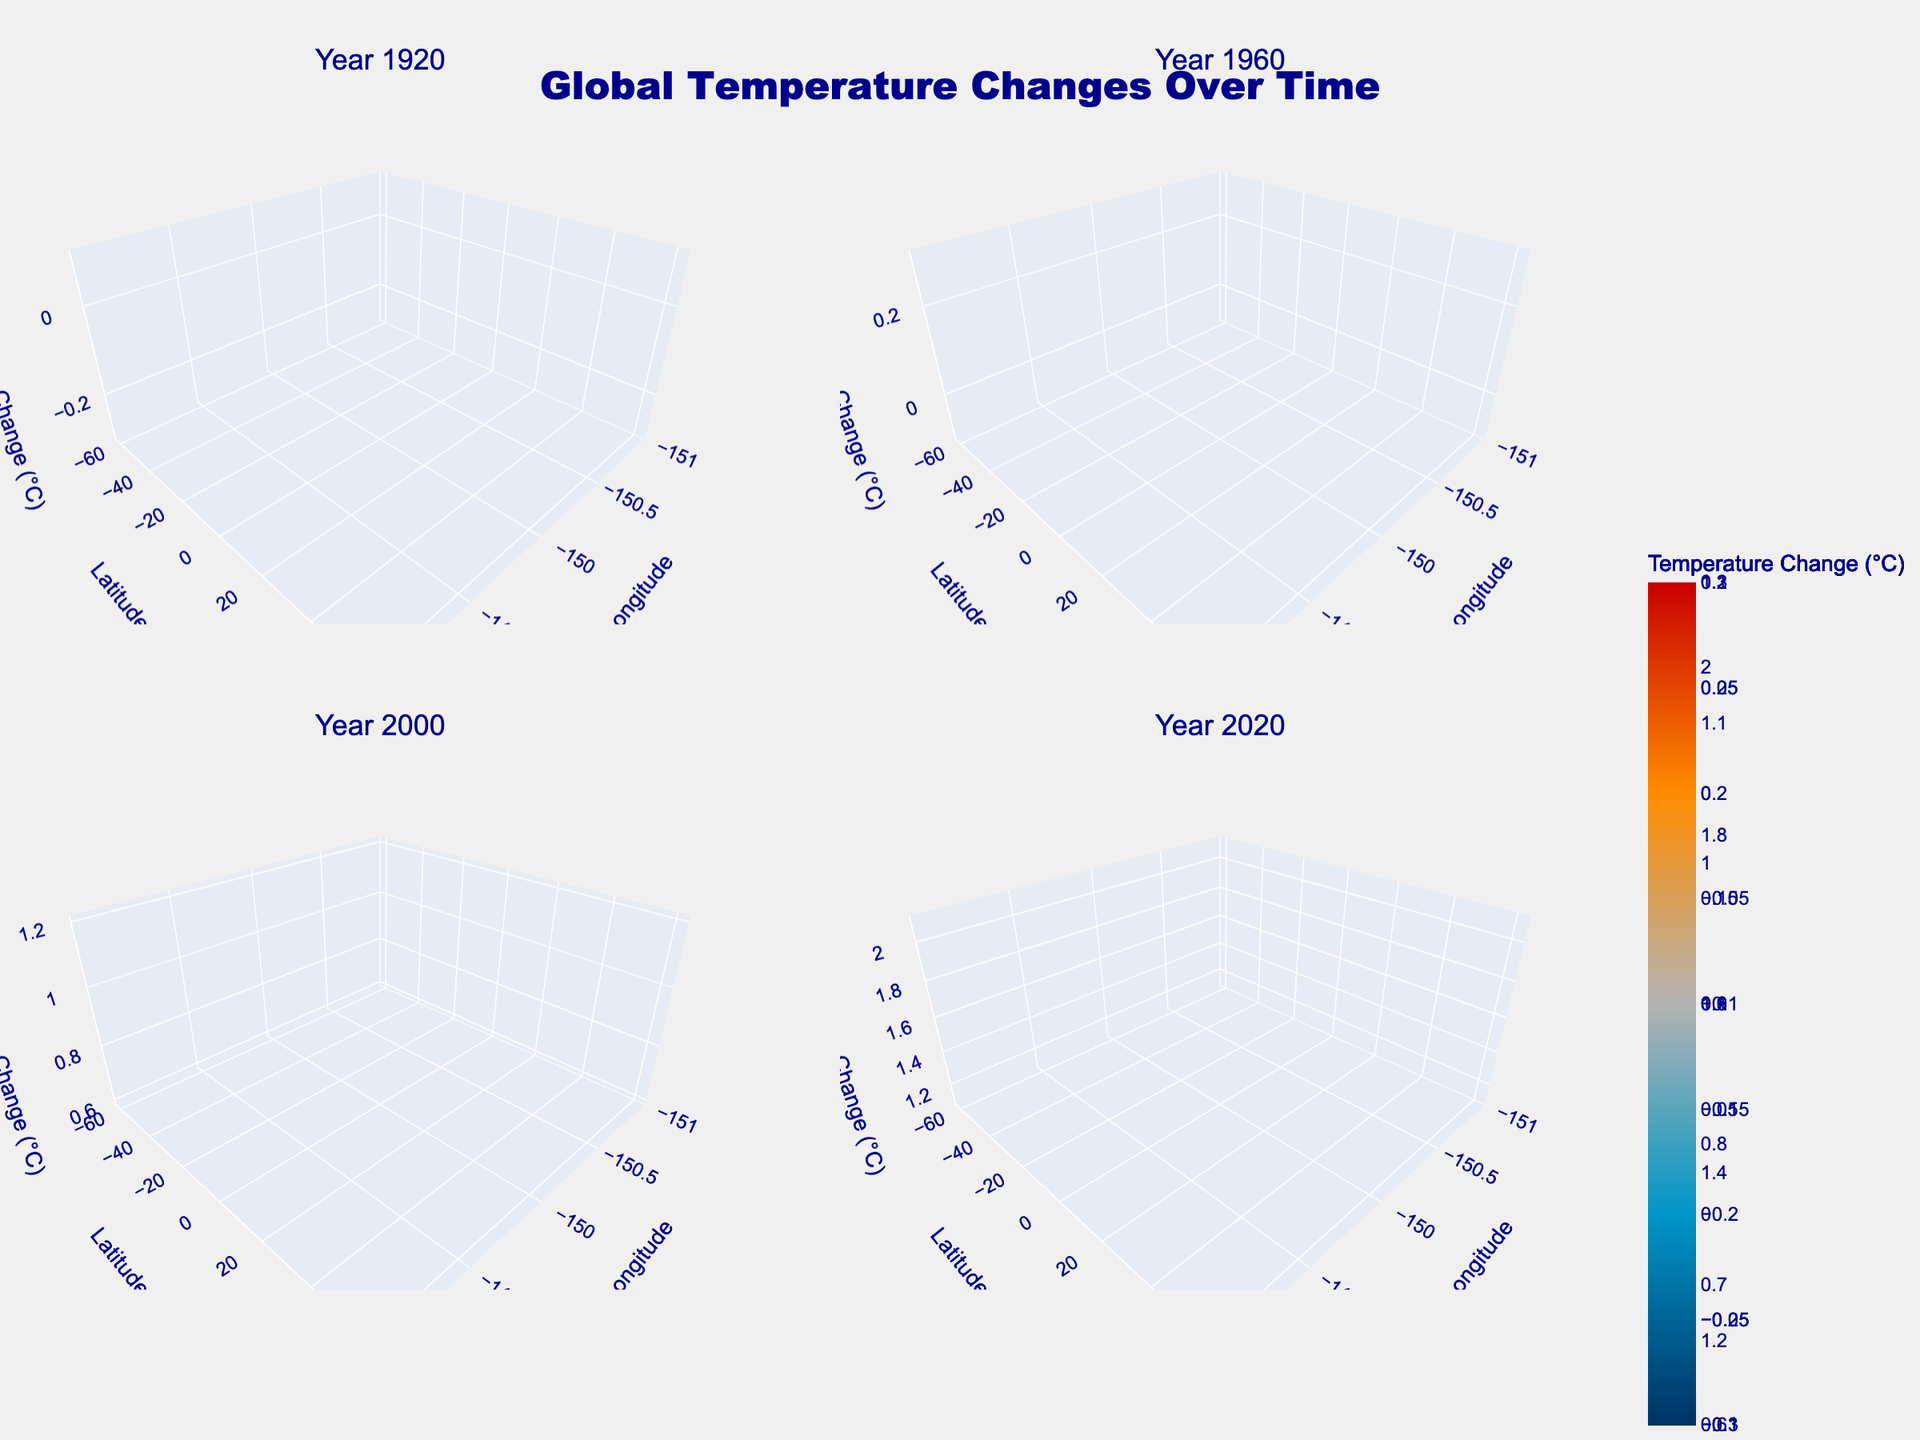What is the title of the figure? The title is usually displayed prominently at the top of the figure. Here, it is "Global Temperature Changes Over Time" as described in the code.
Answer: Global Temperature Changes Over Time Which subplot shows data for the year 1960? The subplot for the year 1960 is listed in the code. It is the second subplot displayed in the top-right corner.
Answer: Top-right What is the color representing the highest temperature change? The highest temperature change correspond to a deep red color based on the provided colorscale ranging from "rgb(0,50,100)" to "rgb(200,0,0)").
Answer: Deep red How many unique latitude points are used in the data? In the data, the unique latitude points can be counted: 60, 30, 0, -30, and -60.
Answer: 5 How did the temperature change between the years 1920 and 2020 at latitude 60, longitude -150? To determine the change, subtract the temperature change at 1920 from that of 2020 for these coordinates: 2.1 - (-0.2).
Answer: +2.3 Compare the temperature changes at latitude 0, longitude 0 in the years 1920 and 2020. Find the temperature changes for these years, which are 0.0 and 1.3, respectively. The increase can be found by subtracting: 1.3 - 0.0.
Answer: +1.3 What trends do you observe from the subplot for the year 2000? Observing the subplot for 2000 reveals a general increase in temperature changes, with most values positive and higher at high latitudes.
Answer: Increase in temperature Is there any latitude where temperature changes decreased between 1960 and 2000? Comparing the data points, latitude -60 shows a temperature change from -0.1 in 1960 to 0.8 in 2000, indicating an increase. So, no latitude shows a decrease.
Answer: No decrease observed Which year shows the most significant overall increase in temperature change? Comparing all years' plots, 2020 shows the most prominent increase, with the highest temperature changes observed across latitudes.
Answer: 2020 Describe the temperature change pattern at latitude -30 over the years. The pattern at latitude -30 shows variations: temperatures decreased from -0.1 in 1920 to 0.0 in 1960, and then increased to 0.6 in 2000 and 1.1 in 2020.
Answer: Decreased then increased 